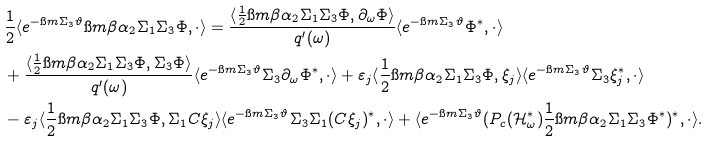Convert formula to latex. <formula><loc_0><loc_0><loc_500><loc_500>& \frac { 1 } { 2 } \langle e ^ { - \i m \Sigma _ { 3 } \vartheta } \i m \beta \alpha _ { 2 } \Sigma _ { 1 } \Sigma _ { 3 } \Phi , \cdot \rangle = \frac { \langle \frac { 1 } { 2 } \i m \beta \alpha _ { 2 } \Sigma _ { 1 } \Sigma _ { 3 } \Phi , \partial _ { \omega } \Phi \rangle } { q ^ { \prime } ( \omega ) } \langle e ^ { - \i m \Sigma _ { 3 } \vartheta } \Phi ^ { * } , \cdot \rangle \\ & + \frac { \langle \frac { 1 } { 2 } \i m \beta \alpha _ { 2 } \Sigma _ { 1 } \Sigma _ { 3 } \Phi , \Sigma _ { 3 } \Phi \rangle } { q ^ { \prime } ( \omega ) } \langle e ^ { - \i m \Sigma _ { 3 } \vartheta } \Sigma _ { 3 } \partial _ { \omega } \Phi ^ { * } , \cdot \rangle + \varepsilon _ { j } \langle \frac { 1 } { 2 } \i m \beta \alpha _ { 2 } \Sigma _ { 1 } \Sigma _ { 3 } \Phi , \xi _ { j } \rangle \langle e ^ { - \i m \Sigma _ { 3 } \vartheta } \Sigma _ { 3 } \xi _ { j } ^ { * } , \cdot \rangle \\ & - \varepsilon _ { j } \langle \frac { 1 } { 2 } \i m \beta \alpha _ { 2 } \Sigma _ { 1 } \Sigma _ { 3 } \Phi , \Sigma _ { 1 } C \xi _ { j } \rangle \langle e ^ { - \i m \Sigma _ { 3 } \vartheta } \Sigma _ { 3 } \Sigma _ { 1 } ( C \xi _ { j } ) ^ { * } , \cdot \rangle + \langle e ^ { - \i m \Sigma _ { 3 } \vartheta } ( P _ { c } ( \mathcal { H } _ { \omega } ^ { * } ) \frac { 1 } { 2 } \i m \beta \alpha _ { 2 } \Sigma _ { 1 } \Sigma _ { 3 } \Phi ^ { * } ) ^ { * } , \cdot \rangle .</formula> 